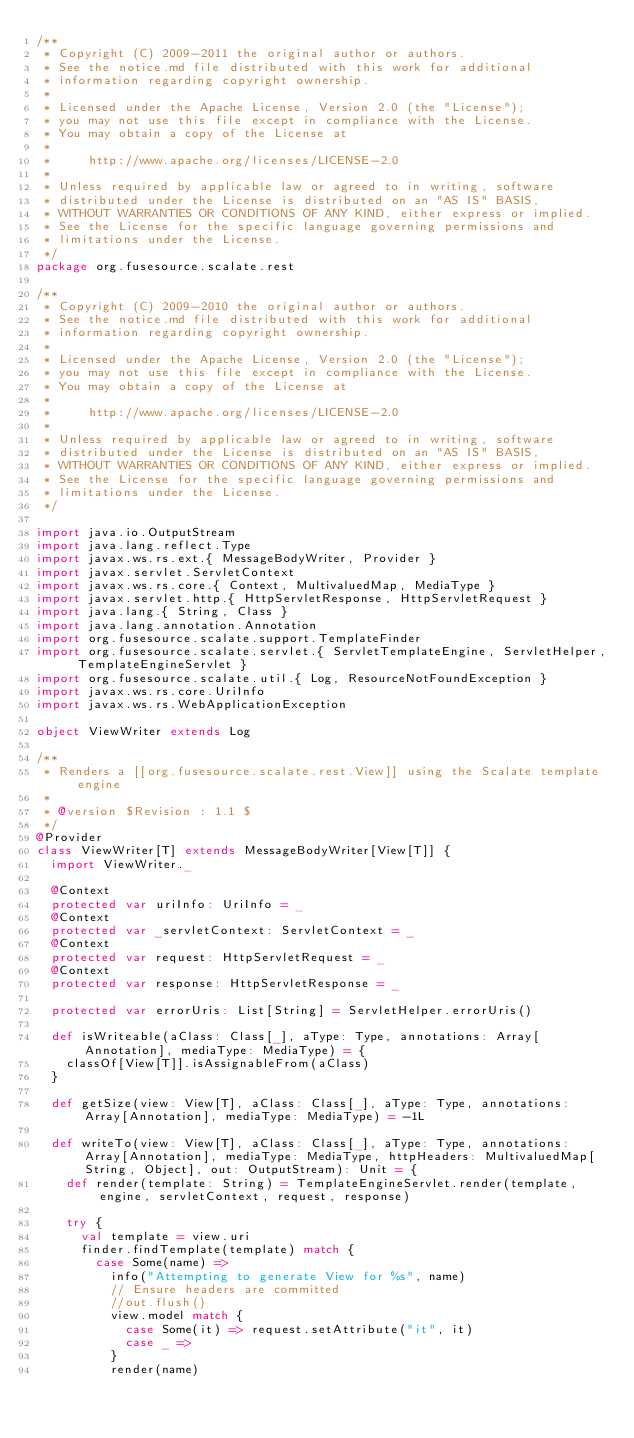<code> <loc_0><loc_0><loc_500><loc_500><_Scala_>/**
 * Copyright (C) 2009-2011 the original author or authors.
 * See the notice.md file distributed with this work for additional
 * information regarding copyright ownership.
 *
 * Licensed under the Apache License, Version 2.0 (the "License");
 * you may not use this file except in compliance with the License.
 * You may obtain a copy of the License at
 *
 *     http://www.apache.org/licenses/LICENSE-2.0
 *
 * Unless required by applicable law or agreed to in writing, software
 * distributed under the License is distributed on an "AS IS" BASIS,
 * WITHOUT WARRANTIES OR CONDITIONS OF ANY KIND, either express or implied.
 * See the License for the specific language governing permissions and
 * limitations under the License.
 */
package org.fusesource.scalate.rest

/**
 * Copyright (C) 2009-2010 the original author or authors.
 * See the notice.md file distributed with this work for additional
 * information regarding copyright ownership.
 *
 * Licensed under the Apache License, Version 2.0 (the "License");
 * you may not use this file except in compliance with the License.
 * You may obtain a copy of the License at
 *
 *     http://www.apache.org/licenses/LICENSE-2.0
 *
 * Unless required by applicable law or agreed to in writing, software
 * distributed under the License is distributed on an "AS IS" BASIS,
 * WITHOUT WARRANTIES OR CONDITIONS OF ANY KIND, either express or implied.
 * See the License for the specific language governing permissions and
 * limitations under the License.
 */

import java.io.OutputStream
import java.lang.reflect.Type
import javax.ws.rs.ext.{ MessageBodyWriter, Provider }
import javax.servlet.ServletContext
import javax.ws.rs.core.{ Context, MultivaluedMap, MediaType }
import javax.servlet.http.{ HttpServletResponse, HttpServletRequest }
import java.lang.{ String, Class }
import java.lang.annotation.Annotation
import org.fusesource.scalate.support.TemplateFinder
import org.fusesource.scalate.servlet.{ ServletTemplateEngine, ServletHelper, TemplateEngineServlet }
import org.fusesource.scalate.util.{ Log, ResourceNotFoundException }
import javax.ws.rs.core.UriInfo
import javax.ws.rs.WebApplicationException

object ViewWriter extends Log

/**
 * Renders a [[org.fusesource.scalate.rest.View]] using the Scalate template engine
 *
 * @version $Revision : 1.1 $
 */
@Provider
class ViewWriter[T] extends MessageBodyWriter[View[T]] {
  import ViewWriter._

  @Context
  protected var uriInfo: UriInfo = _
  @Context
  protected var _servletContext: ServletContext = _
  @Context
  protected var request: HttpServletRequest = _
  @Context
  protected var response: HttpServletResponse = _

  protected var errorUris: List[String] = ServletHelper.errorUris()

  def isWriteable(aClass: Class[_], aType: Type, annotations: Array[Annotation], mediaType: MediaType) = {
    classOf[View[T]].isAssignableFrom(aClass)
  }

  def getSize(view: View[T], aClass: Class[_], aType: Type, annotations: Array[Annotation], mediaType: MediaType) = -1L

  def writeTo(view: View[T], aClass: Class[_], aType: Type, annotations: Array[Annotation], mediaType: MediaType, httpHeaders: MultivaluedMap[String, Object], out: OutputStream): Unit = {
    def render(template: String) = TemplateEngineServlet.render(template, engine, servletContext, request, response)

    try {
      val template = view.uri
      finder.findTemplate(template) match {
        case Some(name) =>
          info("Attempting to generate View for %s", name)
          // Ensure headers are committed
          //out.flush()
          view.model match {
            case Some(it) => request.setAttribute("it", it)
            case _ =>
          }
          render(name)
</code> 